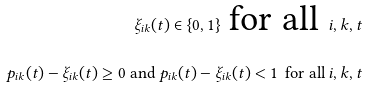Convert formula to latex. <formula><loc_0><loc_0><loc_500><loc_500>\xi _ { i k } ( t ) \in \{ 0 , 1 \} \text { for all } \, i , k , t \\ p _ { i k } ( t ) - \xi _ { i k } ( t ) \geq 0 \text { and } p _ { i k } ( t ) - \xi _ { i k } ( t ) < 1 \, \text { for all } i , k , t</formula> 